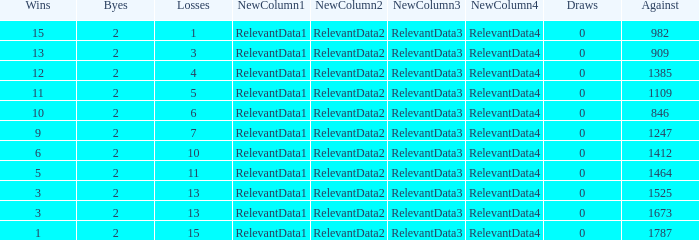What is the average number of Byes when there were less than 0 losses and were against 1247? None. 